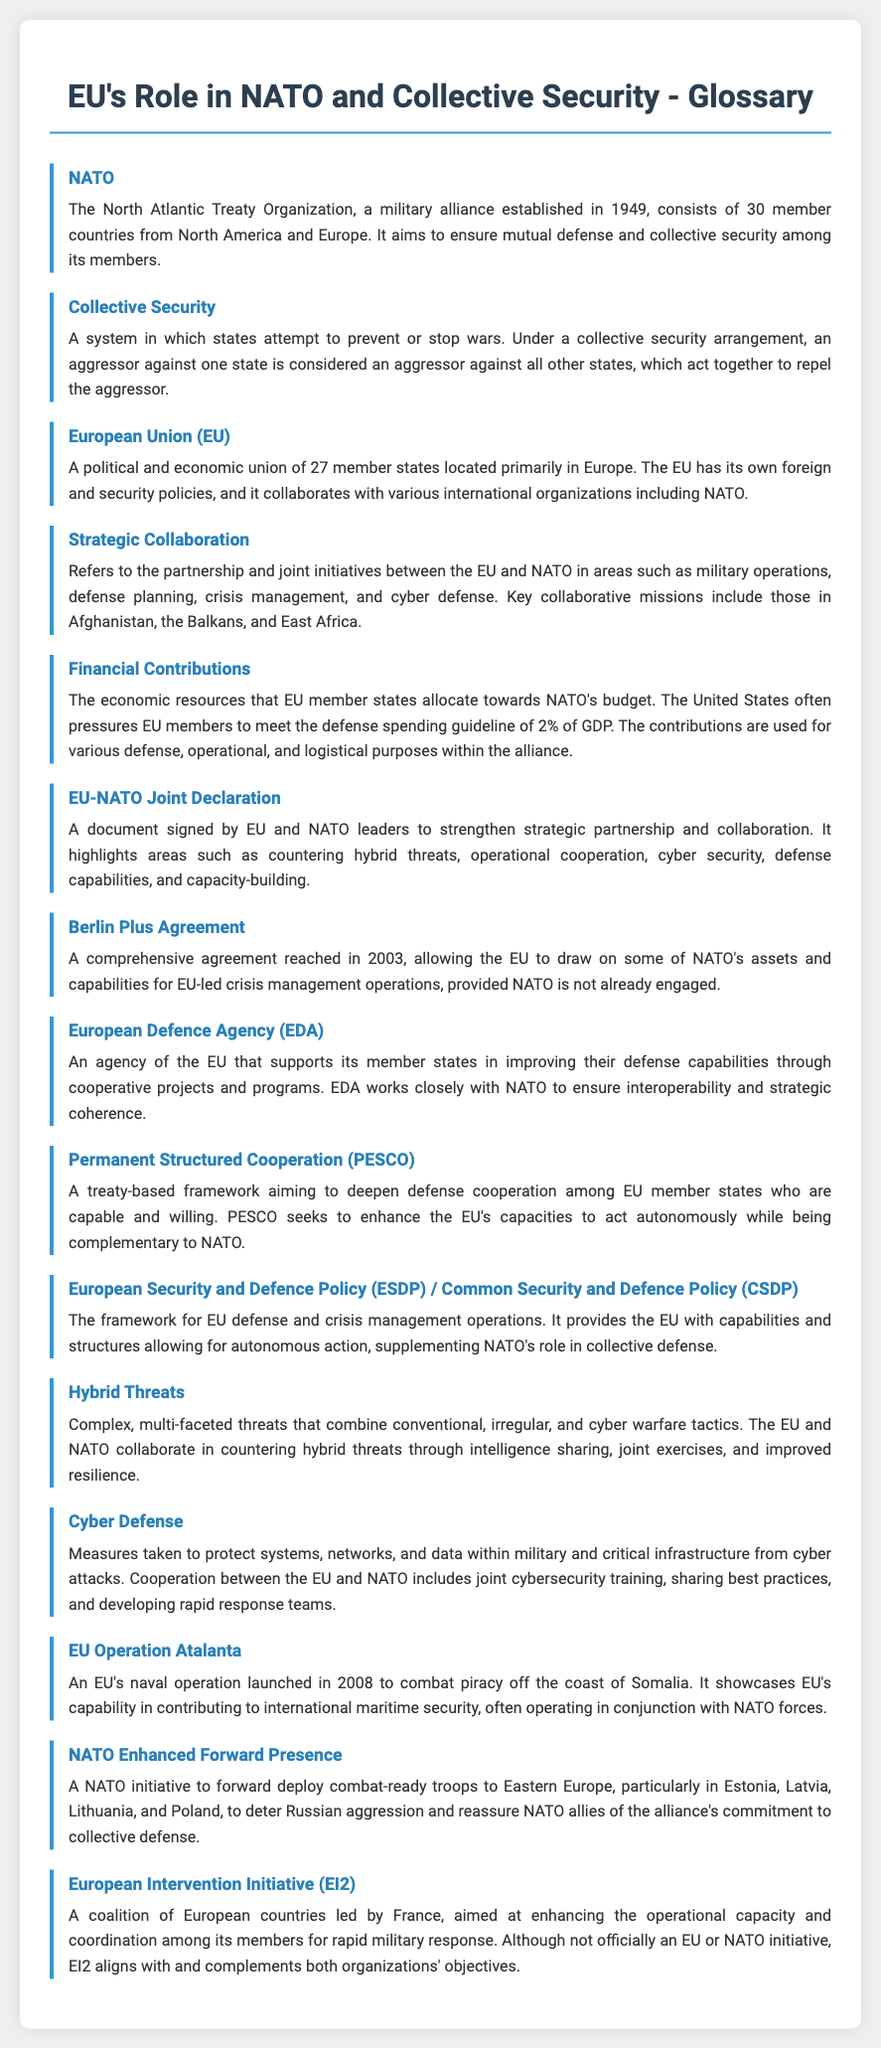What does NATO stand for? NATO stands for the North Atlantic Treaty Organization, which is a military alliance established in 1949.
Answer: North Atlantic Treaty Organization What is collective security? Collective security is a system in which states attempt to prevent or stop wars by acting against an aggressor.
Answer: A system to prevent or stop wars How many member states are in the European Union? The document states that the European Union consists of 27 member states.
Answer: 27 What is the purpose of the EU-NATO Joint Declaration? The EU-NATO Joint Declaration aims to strengthen strategic partnership and collaboration between the two entities, particularly in defense areas.
Answer: Strengthen strategic partnership Which agreement allows the EU to use NATO's assets for crisis management? The Berlin Plus Agreement allows the EU to draw on NATO's assets for EU-led crisis management operations.
Answer: Berlin Plus Agreement What initiative aims to counter hybrid threats collaboratively? The initiative to counter hybrid threats includes both EU and NATO cooperation through intelligence sharing and joint exercises.
Answer: Countering hybrid threats What operation was launched by the EU in 2008 to combat piracy? The EU Operation Atalanta was launched in 2008 to combat piracy off the coast of Somalia.
Answer: Operation Atalanta What is the European Defence Agency (EDA)? The European Defence Agency supports EU member states in improving their defense capabilities and works closely with NATO.
Answer: Agency for defense capabilities What does PESCO stand for? PESCO stands for Permanent Structured Cooperation, a framework for deepening defense cooperation among EU member states.
Answer: Permanent Structured Cooperation 